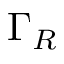<formula> <loc_0><loc_0><loc_500><loc_500>\Gamma _ { R }</formula> 